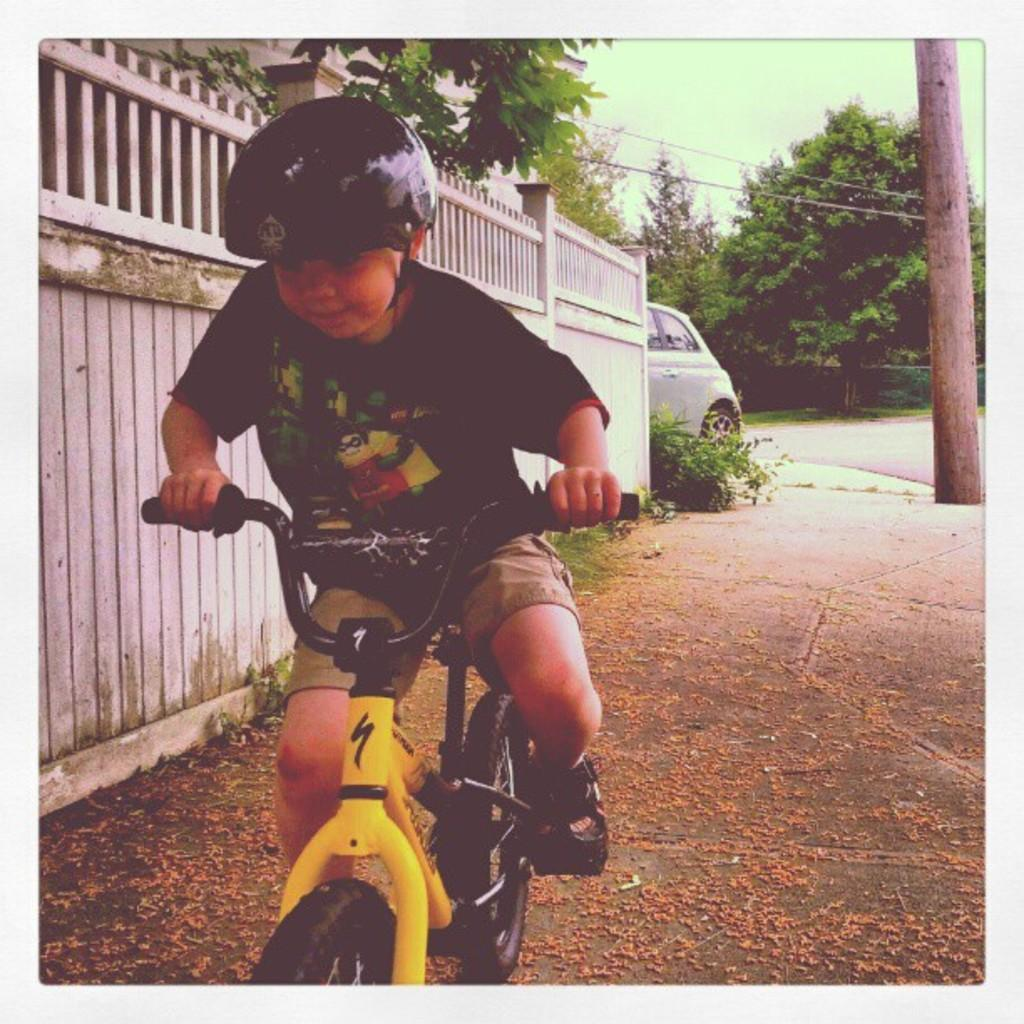What is the main subject of the image? The main subject of the image is a boy. What is the boy doing in the image? The boy is riding a bicycle in the image. What is the boy wearing in the image? The boy is wearing a black T-shirt and a helmet in the image. What can be seen in the background of the image? In the background of the image, there is a fence, a car, trees, a road, wires, and the sky. What type of cannon is being fired on the coast in the image? There is no cannon or coast present in the image. Is the boy skateboarding or riding a bicycle in the image? The boy is riding a bicycle in the image, not skateboarding. 